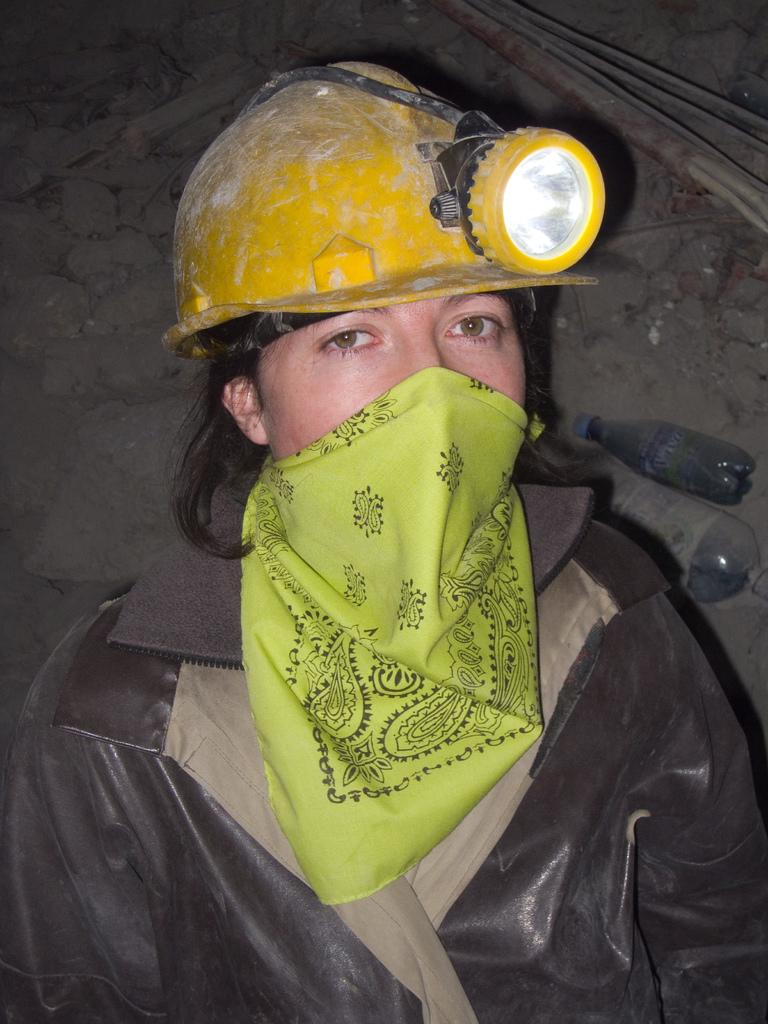Who or what is in the image? There is a person in the image. What is the person wearing around their neck? The person is wearing a scarf. What type of protective gear is the person wearing on their head? The person is wearing a safety helmet. What can be seen besides the person in the image? There is a bottle visible in the image, as well as stones. What is present in the top right corner of the image? Wires are present in the top right corner of the image. Can you see any boats in the harbor in the image? There is no harbor or boats present in the image. What type of stew is being prepared in the stream in the image? There is no stream or stew present in the image. 